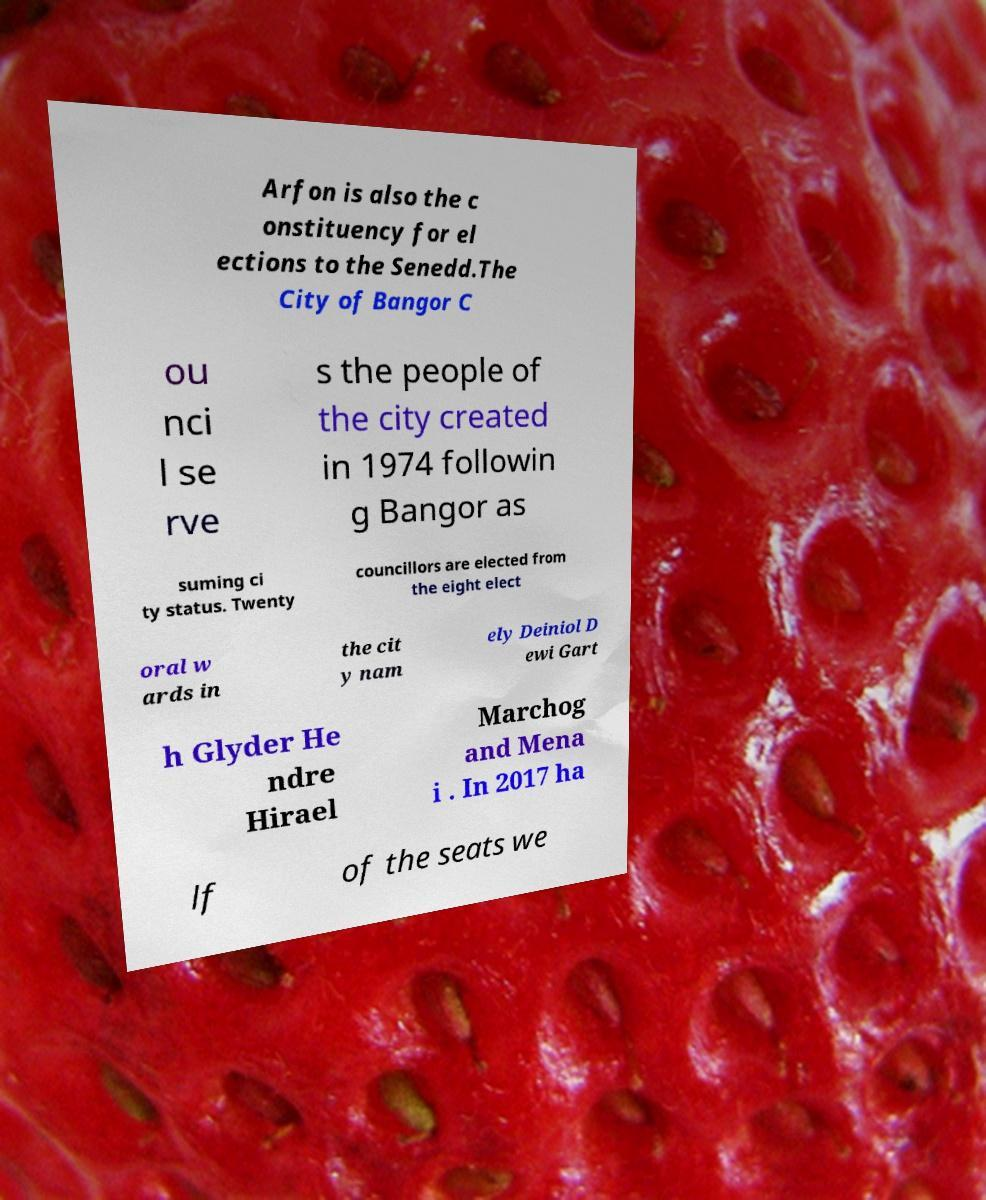Please identify and transcribe the text found in this image. Arfon is also the c onstituency for el ections to the Senedd.The City of Bangor C ou nci l se rve s the people of the city created in 1974 followin g Bangor as suming ci ty status. Twenty councillors are elected from the eight elect oral w ards in the cit y nam ely Deiniol D ewi Gart h Glyder He ndre Hirael Marchog and Mena i . In 2017 ha lf of the seats we 